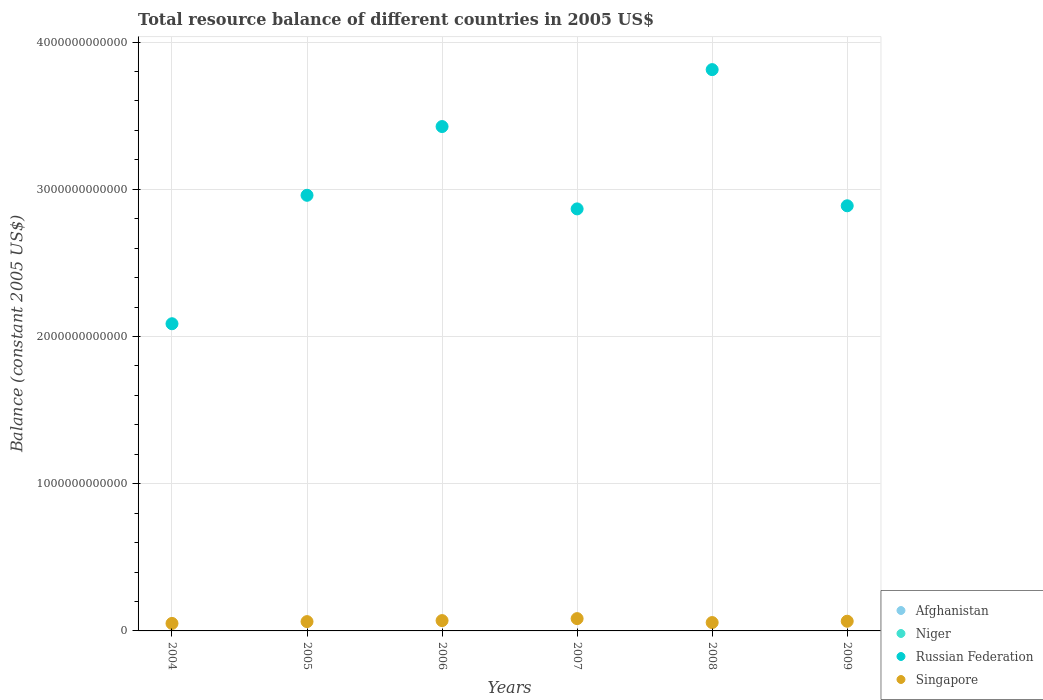How many different coloured dotlines are there?
Provide a short and direct response. 2. Is the number of dotlines equal to the number of legend labels?
Provide a succinct answer. No. What is the total resource balance in Singapore in 2005?
Keep it short and to the point. 6.33e+1. Across all years, what is the maximum total resource balance in Russian Federation?
Provide a short and direct response. 3.81e+12. Across all years, what is the minimum total resource balance in Niger?
Ensure brevity in your answer.  0. What is the total total resource balance in Singapore in the graph?
Provide a short and direct response. 3.91e+11. What is the difference between the total resource balance in Russian Federation in 2004 and that in 2006?
Offer a terse response. -1.34e+12. What is the average total resource balance in Russian Federation per year?
Your answer should be very brief. 3.01e+12. What is the ratio of the total resource balance in Russian Federation in 2005 to that in 2007?
Your answer should be compact. 1.03. What is the difference between the highest and the second highest total resource balance in Russian Federation?
Offer a terse response. 3.87e+11. What is the difference between the highest and the lowest total resource balance in Singapore?
Your answer should be very brief. 3.27e+1. In how many years, is the total resource balance in Niger greater than the average total resource balance in Niger taken over all years?
Offer a very short reply. 0. Is it the case that in every year, the sum of the total resource balance in Afghanistan and total resource balance in Russian Federation  is greater than the total resource balance in Singapore?
Your response must be concise. Yes. Does the total resource balance in Russian Federation monotonically increase over the years?
Ensure brevity in your answer.  No. Is the total resource balance in Singapore strictly greater than the total resource balance in Afghanistan over the years?
Your answer should be very brief. Yes. Is the total resource balance in Singapore strictly less than the total resource balance in Afghanistan over the years?
Ensure brevity in your answer.  No. How many dotlines are there?
Your answer should be compact. 2. What is the difference between two consecutive major ticks on the Y-axis?
Offer a very short reply. 1.00e+12. Are the values on the major ticks of Y-axis written in scientific E-notation?
Your response must be concise. No. Does the graph contain grids?
Provide a short and direct response. Yes. Where does the legend appear in the graph?
Provide a succinct answer. Bottom right. What is the title of the graph?
Provide a succinct answer. Total resource balance of different countries in 2005 US$. What is the label or title of the X-axis?
Offer a very short reply. Years. What is the label or title of the Y-axis?
Provide a succinct answer. Balance (constant 2005 US$). What is the Balance (constant 2005 US$) in Russian Federation in 2004?
Your answer should be compact. 2.09e+12. What is the Balance (constant 2005 US$) in Singapore in 2004?
Make the answer very short. 5.09e+1. What is the Balance (constant 2005 US$) in Niger in 2005?
Your answer should be very brief. 0. What is the Balance (constant 2005 US$) of Russian Federation in 2005?
Your answer should be compact. 2.96e+12. What is the Balance (constant 2005 US$) in Singapore in 2005?
Provide a short and direct response. 6.33e+1. What is the Balance (constant 2005 US$) in Russian Federation in 2006?
Provide a short and direct response. 3.43e+12. What is the Balance (constant 2005 US$) in Singapore in 2006?
Give a very brief answer. 7.01e+1. What is the Balance (constant 2005 US$) of Afghanistan in 2007?
Your answer should be compact. 0. What is the Balance (constant 2005 US$) of Russian Federation in 2007?
Make the answer very short. 2.87e+12. What is the Balance (constant 2005 US$) in Singapore in 2007?
Make the answer very short. 8.36e+1. What is the Balance (constant 2005 US$) of Russian Federation in 2008?
Ensure brevity in your answer.  3.81e+12. What is the Balance (constant 2005 US$) of Singapore in 2008?
Your answer should be compact. 5.68e+1. What is the Balance (constant 2005 US$) of Afghanistan in 2009?
Keep it short and to the point. 0. What is the Balance (constant 2005 US$) of Russian Federation in 2009?
Make the answer very short. 2.89e+12. What is the Balance (constant 2005 US$) of Singapore in 2009?
Give a very brief answer. 6.58e+1. Across all years, what is the maximum Balance (constant 2005 US$) in Russian Federation?
Offer a terse response. 3.81e+12. Across all years, what is the maximum Balance (constant 2005 US$) in Singapore?
Provide a succinct answer. 8.36e+1. Across all years, what is the minimum Balance (constant 2005 US$) of Russian Federation?
Provide a short and direct response. 2.09e+12. Across all years, what is the minimum Balance (constant 2005 US$) in Singapore?
Offer a terse response. 5.09e+1. What is the total Balance (constant 2005 US$) of Niger in the graph?
Your answer should be compact. 0. What is the total Balance (constant 2005 US$) in Russian Federation in the graph?
Give a very brief answer. 1.80e+13. What is the total Balance (constant 2005 US$) in Singapore in the graph?
Your answer should be very brief. 3.91e+11. What is the difference between the Balance (constant 2005 US$) in Russian Federation in 2004 and that in 2005?
Make the answer very short. -8.72e+11. What is the difference between the Balance (constant 2005 US$) in Singapore in 2004 and that in 2005?
Ensure brevity in your answer.  -1.23e+1. What is the difference between the Balance (constant 2005 US$) in Russian Federation in 2004 and that in 2006?
Your answer should be compact. -1.34e+12. What is the difference between the Balance (constant 2005 US$) of Singapore in 2004 and that in 2006?
Provide a short and direct response. -1.92e+1. What is the difference between the Balance (constant 2005 US$) of Russian Federation in 2004 and that in 2007?
Your response must be concise. -7.80e+11. What is the difference between the Balance (constant 2005 US$) of Singapore in 2004 and that in 2007?
Offer a very short reply. -3.27e+1. What is the difference between the Balance (constant 2005 US$) in Russian Federation in 2004 and that in 2008?
Your answer should be very brief. -1.73e+12. What is the difference between the Balance (constant 2005 US$) in Singapore in 2004 and that in 2008?
Provide a succinct answer. -5.88e+09. What is the difference between the Balance (constant 2005 US$) in Russian Federation in 2004 and that in 2009?
Make the answer very short. -8.01e+11. What is the difference between the Balance (constant 2005 US$) in Singapore in 2004 and that in 2009?
Make the answer very short. -1.49e+1. What is the difference between the Balance (constant 2005 US$) in Russian Federation in 2005 and that in 2006?
Your answer should be very brief. -4.67e+11. What is the difference between the Balance (constant 2005 US$) of Singapore in 2005 and that in 2006?
Your response must be concise. -6.84e+09. What is the difference between the Balance (constant 2005 US$) in Russian Federation in 2005 and that in 2007?
Make the answer very short. 9.24e+1. What is the difference between the Balance (constant 2005 US$) in Singapore in 2005 and that in 2007?
Offer a very short reply. -2.04e+1. What is the difference between the Balance (constant 2005 US$) in Russian Federation in 2005 and that in 2008?
Offer a terse response. -8.54e+11. What is the difference between the Balance (constant 2005 US$) of Singapore in 2005 and that in 2008?
Give a very brief answer. 6.47e+09. What is the difference between the Balance (constant 2005 US$) in Russian Federation in 2005 and that in 2009?
Your answer should be very brief. 7.13e+1. What is the difference between the Balance (constant 2005 US$) in Singapore in 2005 and that in 2009?
Offer a terse response. -2.59e+09. What is the difference between the Balance (constant 2005 US$) in Russian Federation in 2006 and that in 2007?
Provide a short and direct response. 5.59e+11. What is the difference between the Balance (constant 2005 US$) in Singapore in 2006 and that in 2007?
Offer a terse response. -1.35e+1. What is the difference between the Balance (constant 2005 US$) in Russian Federation in 2006 and that in 2008?
Keep it short and to the point. -3.87e+11. What is the difference between the Balance (constant 2005 US$) in Singapore in 2006 and that in 2008?
Your response must be concise. 1.33e+1. What is the difference between the Balance (constant 2005 US$) in Russian Federation in 2006 and that in 2009?
Offer a terse response. 5.38e+11. What is the difference between the Balance (constant 2005 US$) of Singapore in 2006 and that in 2009?
Offer a very short reply. 4.25e+09. What is the difference between the Balance (constant 2005 US$) of Russian Federation in 2007 and that in 2008?
Offer a terse response. -9.46e+11. What is the difference between the Balance (constant 2005 US$) of Singapore in 2007 and that in 2008?
Give a very brief answer. 2.68e+1. What is the difference between the Balance (constant 2005 US$) of Russian Federation in 2007 and that in 2009?
Your answer should be compact. -2.11e+1. What is the difference between the Balance (constant 2005 US$) of Singapore in 2007 and that in 2009?
Keep it short and to the point. 1.78e+1. What is the difference between the Balance (constant 2005 US$) of Russian Federation in 2008 and that in 2009?
Your answer should be compact. 9.25e+11. What is the difference between the Balance (constant 2005 US$) of Singapore in 2008 and that in 2009?
Offer a terse response. -9.06e+09. What is the difference between the Balance (constant 2005 US$) in Russian Federation in 2004 and the Balance (constant 2005 US$) in Singapore in 2005?
Give a very brief answer. 2.02e+12. What is the difference between the Balance (constant 2005 US$) of Russian Federation in 2004 and the Balance (constant 2005 US$) of Singapore in 2006?
Your answer should be very brief. 2.02e+12. What is the difference between the Balance (constant 2005 US$) of Russian Federation in 2004 and the Balance (constant 2005 US$) of Singapore in 2007?
Provide a succinct answer. 2.00e+12. What is the difference between the Balance (constant 2005 US$) in Russian Federation in 2004 and the Balance (constant 2005 US$) in Singapore in 2008?
Keep it short and to the point. 2.03e+12. What is the difference between the Balance (constant 2005 US$) in Russian Federation in 2004 and the Balance (constant 2005 US$) in Singapore in 2009?
Make the answer very short. 2.02e+12. What is the difference between the Balance (constant 2005 US$) in Russian Federation in 2005 and the Balance (constant 2005 US$) in Singapore in 2006?
Your response must be concise. 2.89e+12. What is the difference between the Balance (constant 2005 US$) of Russian Federation in 2005 and the Balance (constant 2005 US$) of Singapore in 2007?
Your answer should be compact. 2.88e+12. What is the difference between the Balance (constant 2005 US$) in Russian Federation in 2005 and the Balance (constant 2005 US$) in Singapore in 2008?
Offer a terse response. 2.90e+12. What is the difference between the Balance (constant 2005 US$) in Russian Federation in 2005 and the Balance (constant 2005 US$) in Singapore in 2009?
Give a very brief answer. 2.89e+12. What is the difference between the Balance (constant 2005 US$) of Russian Federation in 2006 and the Balance (constant 2005 US$) of Singapore in 2007?
Your answer should be very brief. 3.34e+12. What is the difference between the Balance (constant 2005 US$) of Russian Federation in 2006 and the Balance (constant 2005 US$) of Singapore in 2008?
Make the answer very short. 3.37e+12. What is the difference between the Balance (constant 2005 US$) in Russian Federation in 2006 and the Balance (constant 2005 US$) in Singapore in 2009?
Offer a very short reply. 3.36e+12. What is the difference between the Balance (constant 2005 US$) in Russian Federation in 2007 and the Balance (constant 2005 US$) in Singapore in 2008?
Your answer should be compact. 2.81e+12. What is the difference between the Balance (constant 2005 US$) in Russian Federation in 2007 and the Balance (constant 2005 US$) in Singapore in 2009?
Provide a succinct answer. 2.80e+12. What is the difference between the Balance (constant 2005 US$) in Russian Federation in 2008 and the Balance (constant 2005 US$) in Singapore in 2009?
Make the answer very short. 3.75e+12. What is the average Balance (constant 2005 US$) of Russian Federation per year?
Provide a succinct answer. 3.01e+12. What is the average Balance (constant 2005 US$) in Singapore per year?
Provide a succinct answer. 6.51e+1. In the year 2004, what is the difference between the Balance (constant 2005 US$) in Russian Federation and Balance (constant 2005 US$) in Singapore?
Make the answer very short. 2.04e+12. In the year 2005, what is the difference between the Balance (constant 2005 US$) in Russian Federation and Balance (constant 2005 US$) in Singapore?
Provide a short and direct response. 2.90e+12. In the year 2006, what is the difference between the Balance (constant 2005 US$) in Russian Federation and Balance (constant 2005 US$) in Singapore?
Provide a short and direct response. 3.36e+12. In the year 2007, what is the difference between the Balance (constant 2005 US$) in Russian Federation and Balance (constant 2005 US$) in Singapore?
Your answer should be very brief. 2.78e+12. In the year 2008, what is the difference between the Balance (constant 2005 US$) in Russian Federation and Balance (constant 2005 US$) in Singapore?
Ensure brevity in your answer.  3.76e+12. In the year 2009, what is the difference between the Balance (constant 2005 US$) of Russian Federation and Balance (constant 2005 US$) of Singapore?
Ensure brevity in your answer.  2.82e+12. What is the ratio of the Balance (constant 2005 US$) of Russian Federation in 2004 to that in 2005?
Provide a succinct answer. 0.71. What is the ratio of the Balance (constant 2005 US$) of Singapore in 2004 to that in 2005?
Your response must be concise. 0.8. What is the ratio of the Balance (constant 2005 US$) in Russian Federation in 2004 to that in 2006?
Offer a very short reply. 0.61. What is the ratio of the Balance (constant 2005 US$) of Singapore in 2004 to that in 2006?
Provide a succinct answer. 0.73. What is the ratio of the Balance (constant 2005 US$) in Russian Federation in 2004 to that in 2007?
Offer a terse response. 0.73. What is the ratio of the Balance (constant 2005 US$) in Singapore in 2004 to that in 2007?
Offer a very short reply. 0.61. What is the ratio of the Balance (constant 2005 US$) of Russian Federation in 2004 to that in 2008?
Your response must be concise. 0.55. What is the ratio of the Balance (constant 2005 US$) in Singapore in 2004 to that in 2008?
Offer a very short reply. 0.9. What is the ratio of the Balance (constant 2005 US$) in Russian Federation in 2004 to that in 2009?
Offer a terse response. 0.72. What is the ratio of the Balance (constant 2005 US$) of Singapore in 2004 to that in 2009?
Offer a very short reply. 0.77. What is the ratio of the Balance (constant 2005 US$) in Russian Federation in 2005 to that in 2006?
Keep it short and to the point. 0.86. What is the ratio of the Balance (constant 2005 US$) in Singapore in 2005 to that in 2006?
Offer a very short reply. 0.9. What is the ratio of the Balance (constant 2005 US$) of Russian Federation in 2005 to that in 2007?
Offer a terse response. 1.03. What is the ratio of the Balance (constant 2005 US$) of Singapore in 2005 to that in 2007?
Make the answer very short. 0.76. What is the ratio of the Balance (constant 2005 US$) in Russian Federation in 2005 to that in 2008?
Offer a very short reply. 0.78. What is the ratio of the Balance (constant 2005 US$) of Singapore in 2005 to that in 2008?
Offer a terse response. 1.11. What is the ratio of the Balance (constant 2005 US$) of Russian Federation in 2005 to that in 2009?
Your answer should be very brief. 1.02. What is the ratio of the Balance (constant 2005 US$) in Singapore in 2005 to that in 2009?
Offer a very short reply. 0.96. What is the ratio of the Balance (constant 2005 US$) in Russian Federation in 2006 to that in 2007?
Your answer should be compact. 1.2. What is the ratio of the Balance (constant 2005 US$) in Singapore in 2006 to that in 2007?
Your response must be concise. 0.84. What is the ratio of the Balance (constant 2005 US$) of Russian Federation in 2006 to that in 2008?
Your answer should be very brief. 0.9. What is the ratio of the Balance (constant 2005 US$) in Singapore in 2006 to that in 2008?
Provide a short and direct response. 1.23. What is the ratio of the Balance (constant 2005 US$) in Russian Federation in 2006 to that in 2009?
Provide a succinct answer. 1.19. What is the ratio of the Balance (constant 2005 US$) of Singapore in 2006 to that in 2009?
Offer a terse response. 1.06. What is the ratio of the Balance (constant 2005 US$) in Russian Federation in 2007 to that in 2008?
Your answer should be compact. 0.75. What is the ratio of the Balance (constant 2005 US$) of Singapore in 2007 to that in 2008?
Give a very brief answer. 1.47. What is the ratio of the Balance (constant 2005 US$) of Russian Federation in 2007 to that in 2009?
Your answer should be very brief. 0.99. What is the ratio of the Balance (constant 2005 US$) of Singapore in 2007 to that in 2009?
Offer a terse response. 1.27. What is the ratio of the Balance (constant 2005 US$) in Russian Federation in 2008 to that in 2009?
Your response must be concise. 1.32. What is the ratio of the Balance (constant 2005 US$) of Singapore in 2008 to that in 2009?
Keep it short and to the point. 0.86. What is the difference between the highest and the second highest Balance (constant 2005 US$) in Russian Federation?
Offer a very short reply. 3.87e+11. What is the difference between the highest and the second highest Balance (constant 2005 US$) of Singapore?
Provide a short and direct response. 1.35e+1. What is the difference between the highest and the lowest Balance (constant 2005 US$) of Russian Federation?
Offer a terse response. 1.73e+12. What is the difference between the highest and the lowest Balance (constant 2005 US$) in Singapore?
Provide a short and direct response. 3.27e+1. 